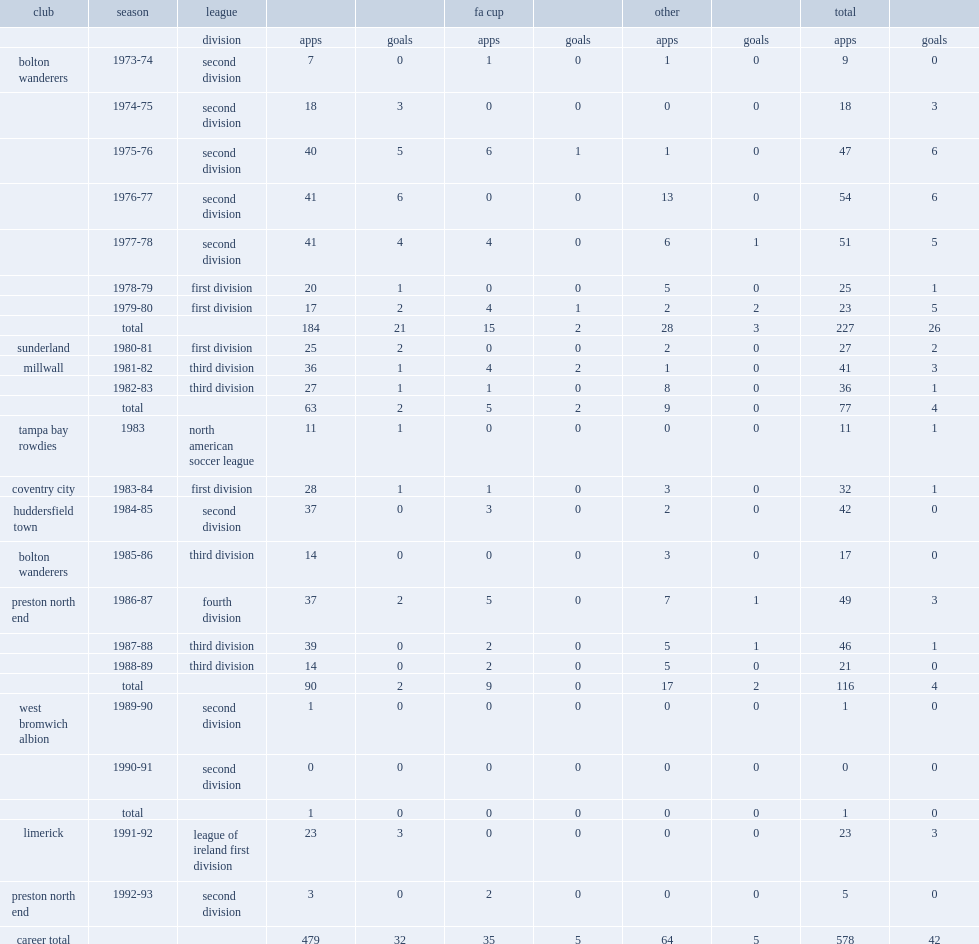Which league did allardyce play for limerick in the 1991-92 season? League of ireland first division. 